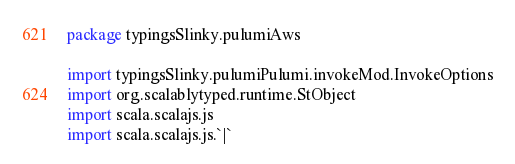<code> <loc_0><loc_0><loc_500><loc_500><_Scala_>package typingsSlinky.pulumiAws

import typingsSlinky.pulumiPulumi.invokeMod.InvokeOptions
import org.scalablytyped.runtime.StObject
import scala.scalajs.js
import scala.scalajs.js.`|`</code> 